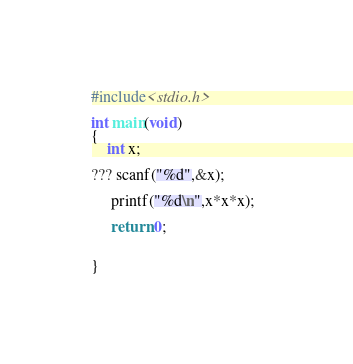Convert code to text. <code><loc_0><loc_0><loc_500><loc_500><_C_>#include<stdio.h>

int main(void)
{
    int x;

??? scanf("%d",&x);

     printf("%d\n",x*x*x);  

     return 0;


}</code> 